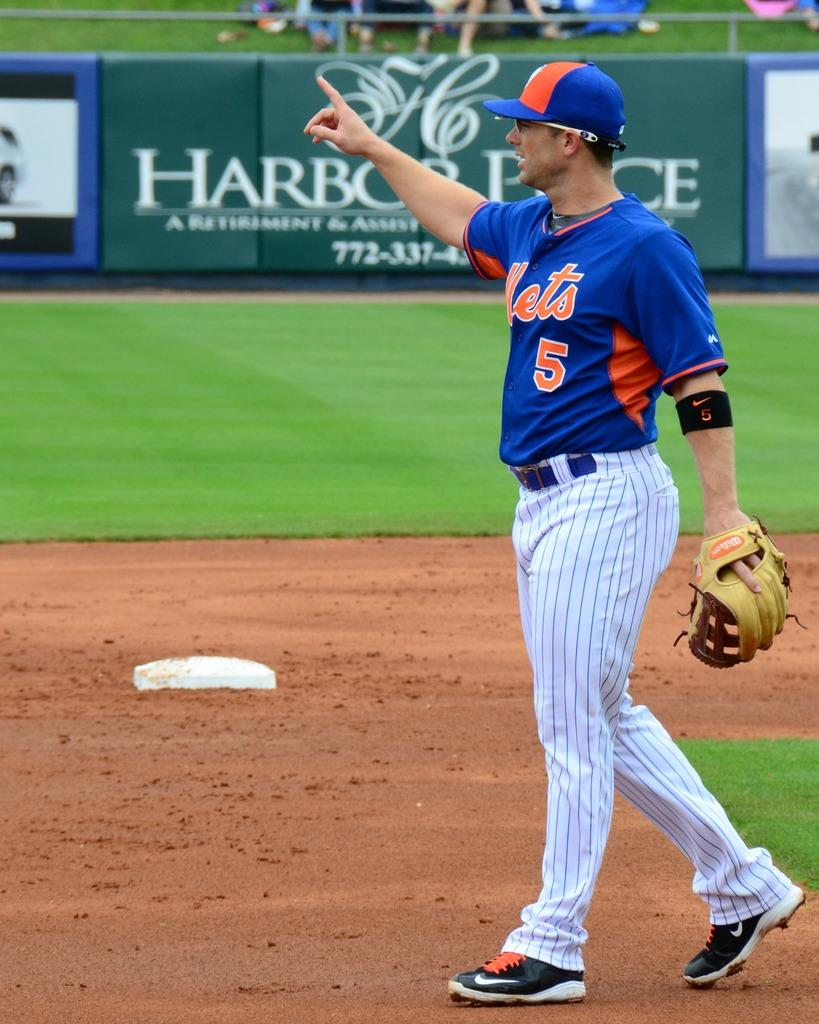Provide a one-sentence caption for the provided image. The basebal player wearing jersey no 5 plays for the Mets. 